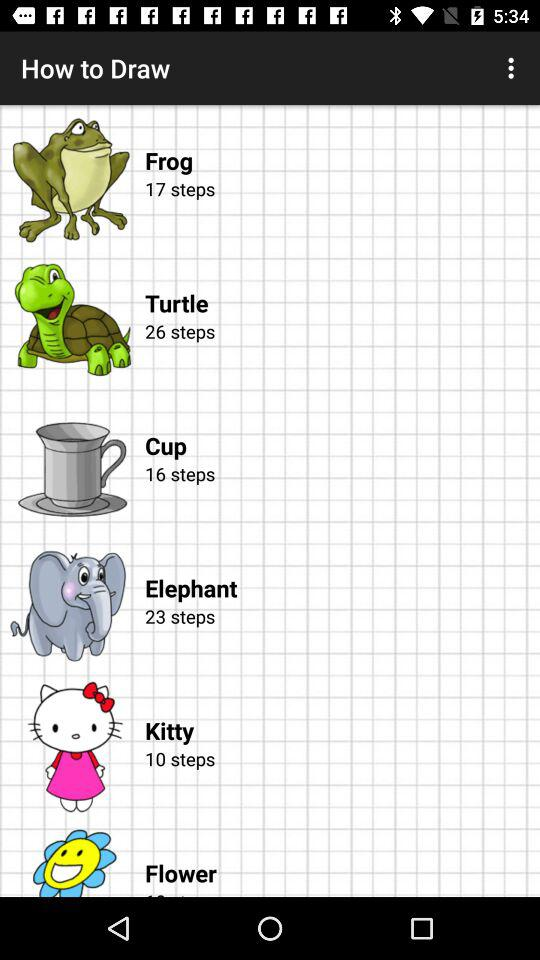How many steps are given for an elephant? The steps given for an elephant are 23. 